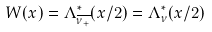Convert formula to latex. <formula><loc_0><loc_0><loc_500><loc_500>W ( x ) = \Lambda ^ { \ast } _ { \overline { \nu _ { + } } } ( x / 2 ) = \Lambda ^ { \ast } _ { \nu } ( x / 2 )</formula> 